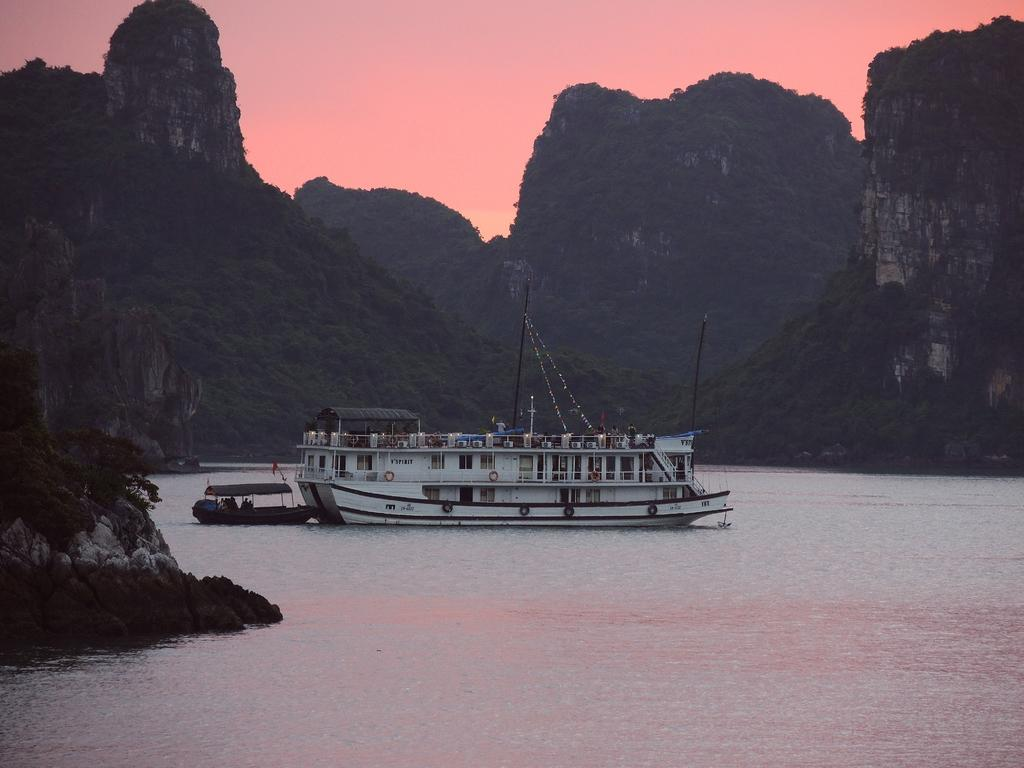What is the main element in the image? There is water in the image. What can be seen floating on the water? There are two boats in the water. How would you describe the background of the image? The background of the image has an orange color. Is there any text or writing visible in the image? Yes, there is writing on one of the boats. What type of crack is visible on the boat in the image? There is no crack visible on the boat in the image. What color are the trousers of the person on the boat? There are no people or trousers present in the image. Can you tell me the size of the vase on the boat? There is no vase present in the image. 